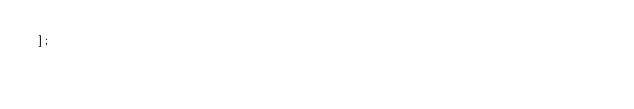<code> <loc_0><loc_0><loc_500><loc_500><_JavaScript_>];</code> 